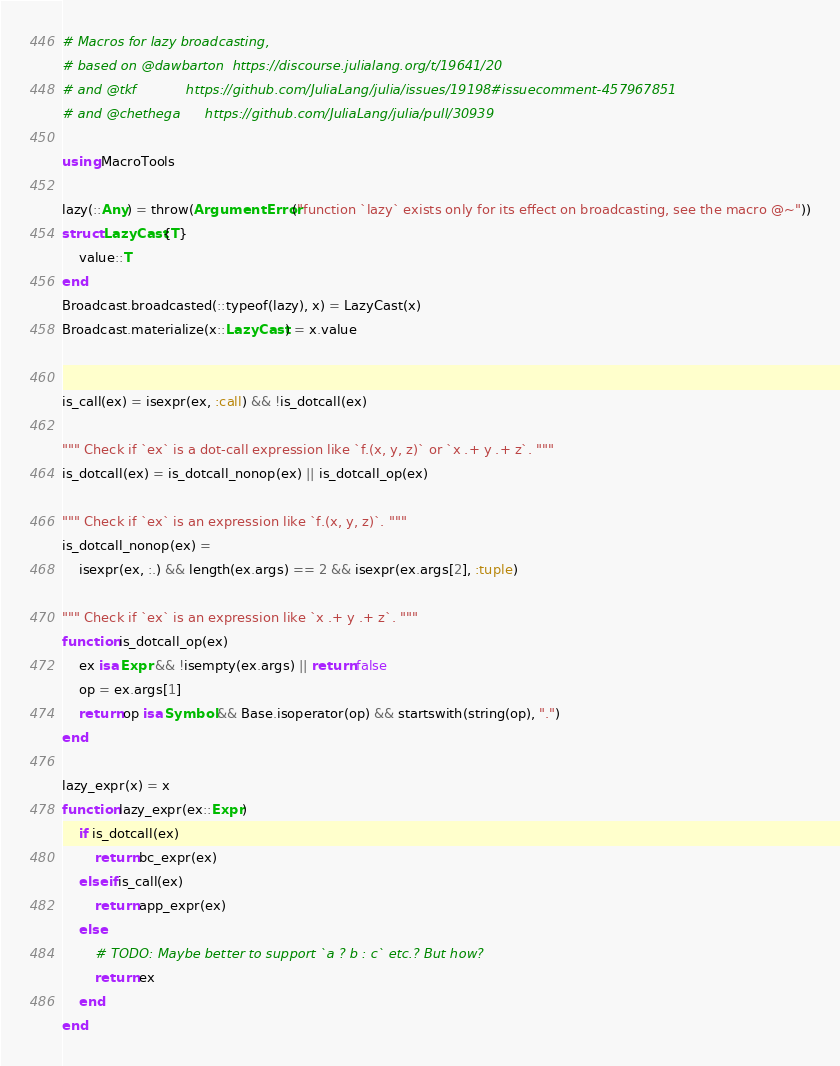Convert code to text. <code><loc_0><loc_0><loc_500><loc_500><_Julia_># Macros for lazy broadcasting,
# based on @dawbarton  https://discourse.julialang.org/t/19641/20
# and @tkf            https://github.com/JuliaLang/julia/issues/19198#issuecomment-457967851
# and @chethega      https://github.com/JuliaLang/julia/pull/30939

using MacroTools

lazy(::Any) = throw(ArgumentError("function `lazy` exists only for its effect on broadcasting, see the macro @~"))
struct LazyCast{T}
    value::T
end
Broadcast.broadcasted(::typeof(lazy), x) = LazyCast(x)
Broadcast.materialize(x::LazyCast) = x.value


is_call(ex) = isexpr(ex, :call) && !is_dotcall(ex)

""" Check if `ex` is a dot-call expression like `f.(x, y, z)` or `x .+ y .+ z`. """
is_dotcall(ex) = is_dotcall_nonop(ex) || is_dotcall_op(ex)

""" Check if `ex` is an expression like `f.(x, y, z)`. """
is_dotcall_nonop(ex) =
    isexpr(ex, :.) && length(ex.args) == 2 && isexpr(ex.args[2], :tuple)

""" Check if `ex` is an expression like `x .+ y .+ z`. """
function is_dotcall_op(ex)
    ex isa Expr && !isempty(ex.args) || return false
    op = ex.args[1]
    return op isa Symbol && Base.isoperator(op) && startswith(string(op), ".")
end

lazy_expr(x) = x
function lazy_expr(ex::Expr)
    if is_dotcall(ex)
        return bc_expr(ex)
    elseif is_call(ex)
        return app_expr(ex)
    else
        # TODO: Maybe better to support `a ? b : c` etc.? But how?
        return ex
    end
end
</code> 